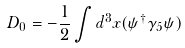<formula> <loc_0><loc_0><loc_500><loc_500>D _ { 0 } = - \frac { 1 } { 2 } \int d ^ { 3 } { x } ( \psi ^ { \dag } \gamma _ { 5 } \psi )</formula> 